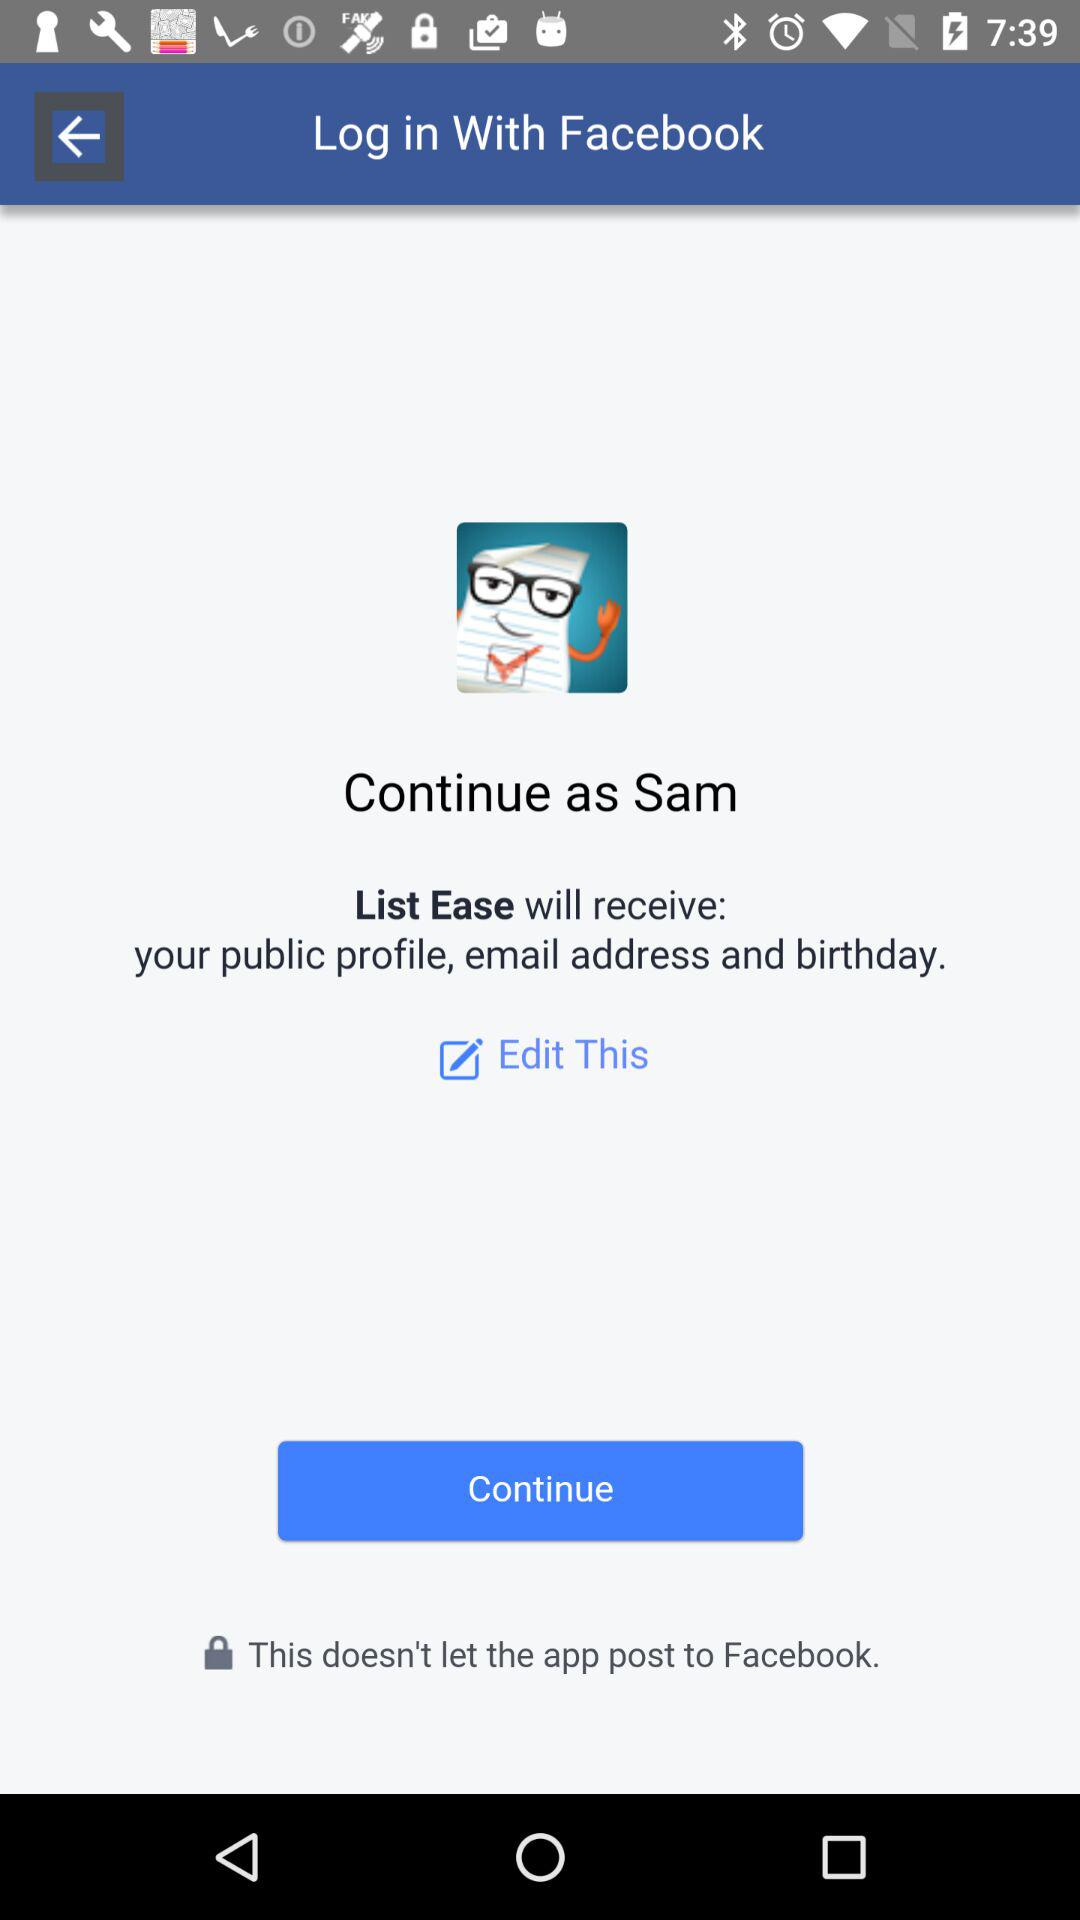What is the name of the user? The name of the user is Sam. 